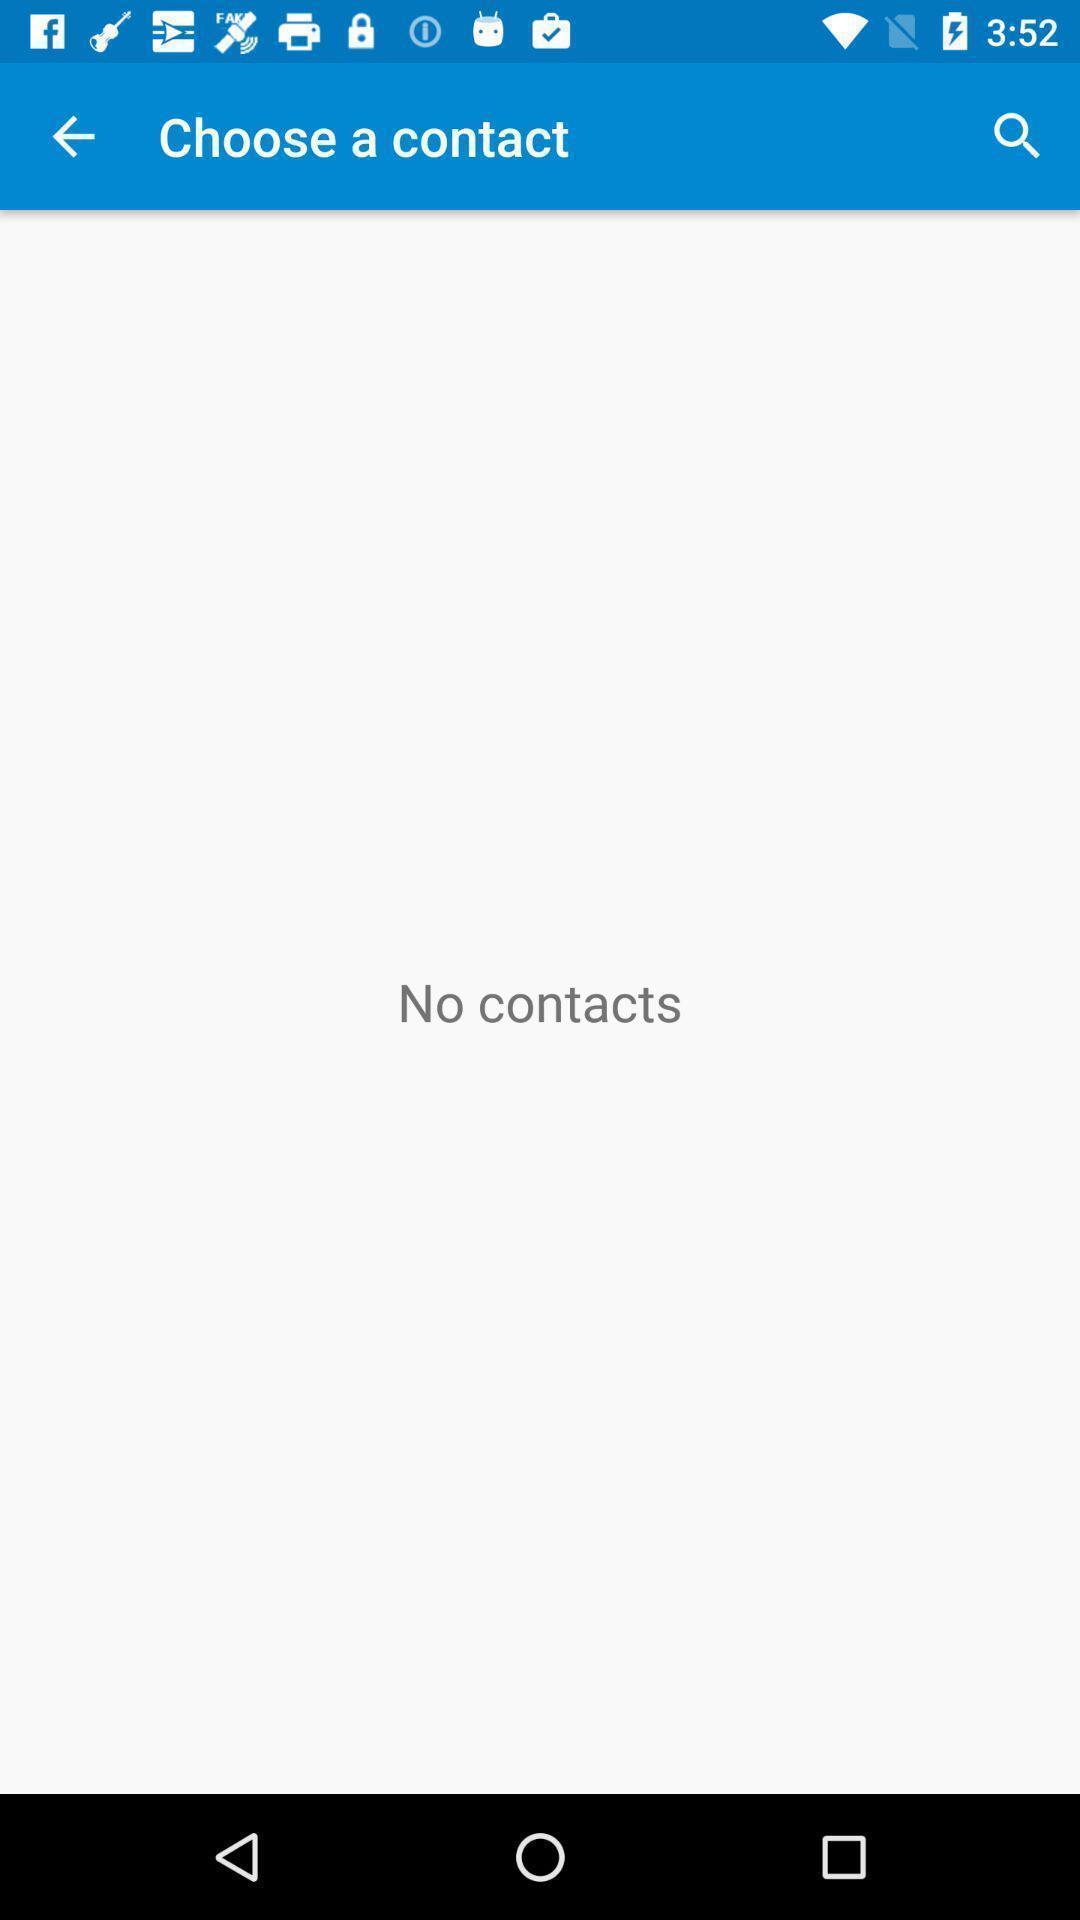Describe the visual elements of this screenshot. Search bar to check the contacts in application. 